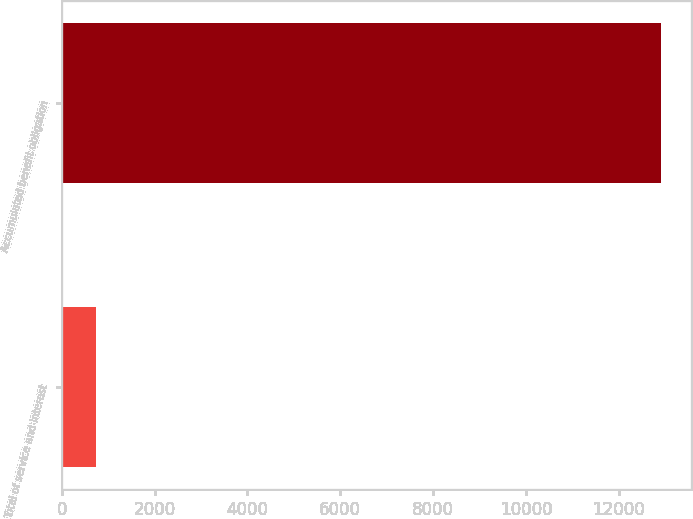Convert chart to OTSL. <chart><loc_0><loc_0><loc_500><loc_500><bar_chart><fcel>Total of service and interest<fcel>Accumulated benefit obligation<nl><fcel>747<fcel>12909<nl></chart> 